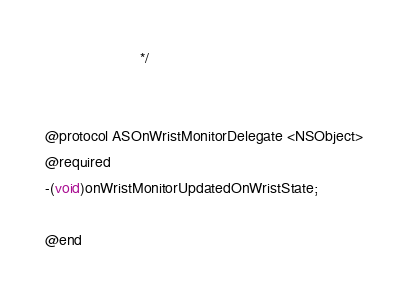Convert code to text. <code><loc_0><loc_0><loc_500><loc_500><_C_>                       */


@protocol ASOnWristMonitorDelegate <NSObject>
@required
-(void)onWristMonitorUpdatedOnWristState;

@end

</code> 